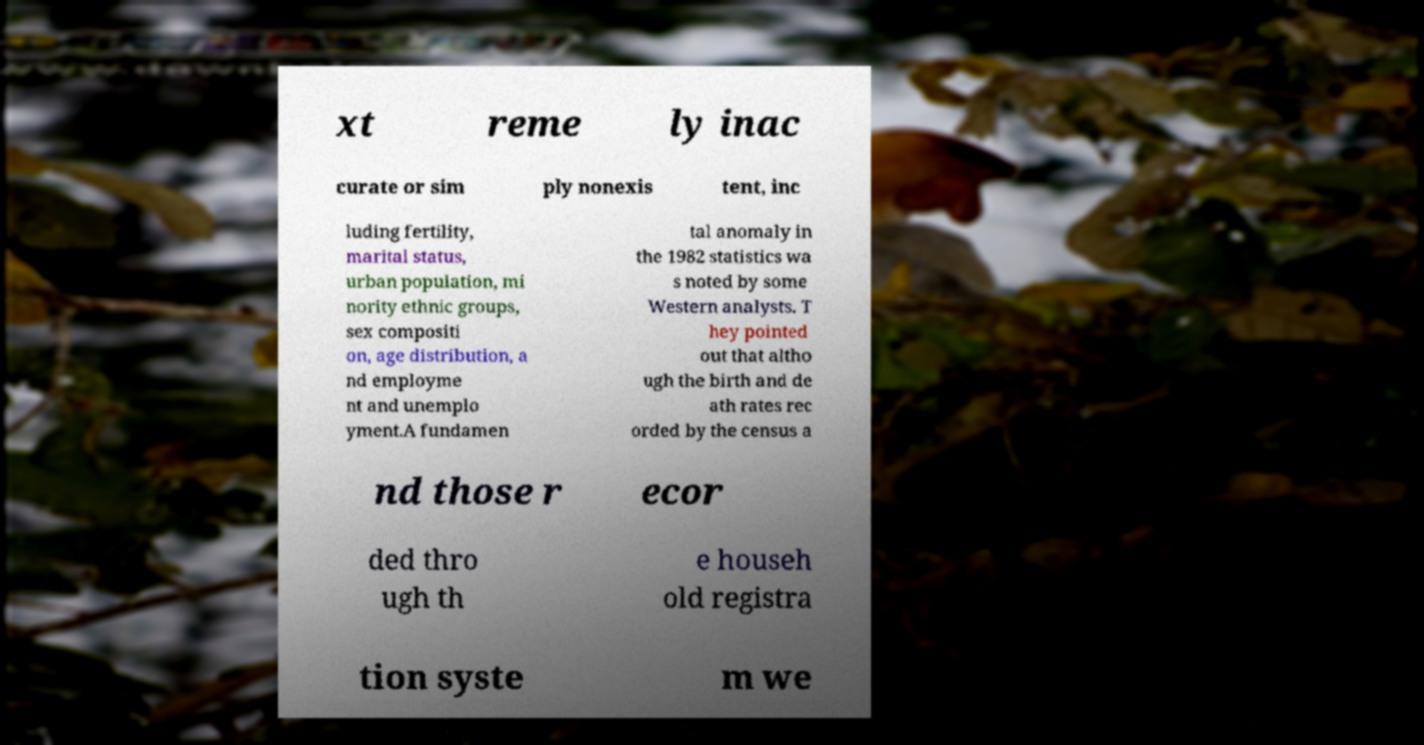Please identify and transcribe the text found in this image. xt reme ly inac curate or sim ply nonexis tent, inc luding fertility, marital status, urban population, mi nority ethnic groups, sex compositi on, age distribution, a nd employme nt and unemplo yment.A fundamen tal anomaly in the 1982 statistics wa s noted by some Western analysts. T hey pointed out that altho ugh the birth and de ath rates rec orded by the census a nd those r ecor ded thro ugh th e househ old registra tion syste m we 